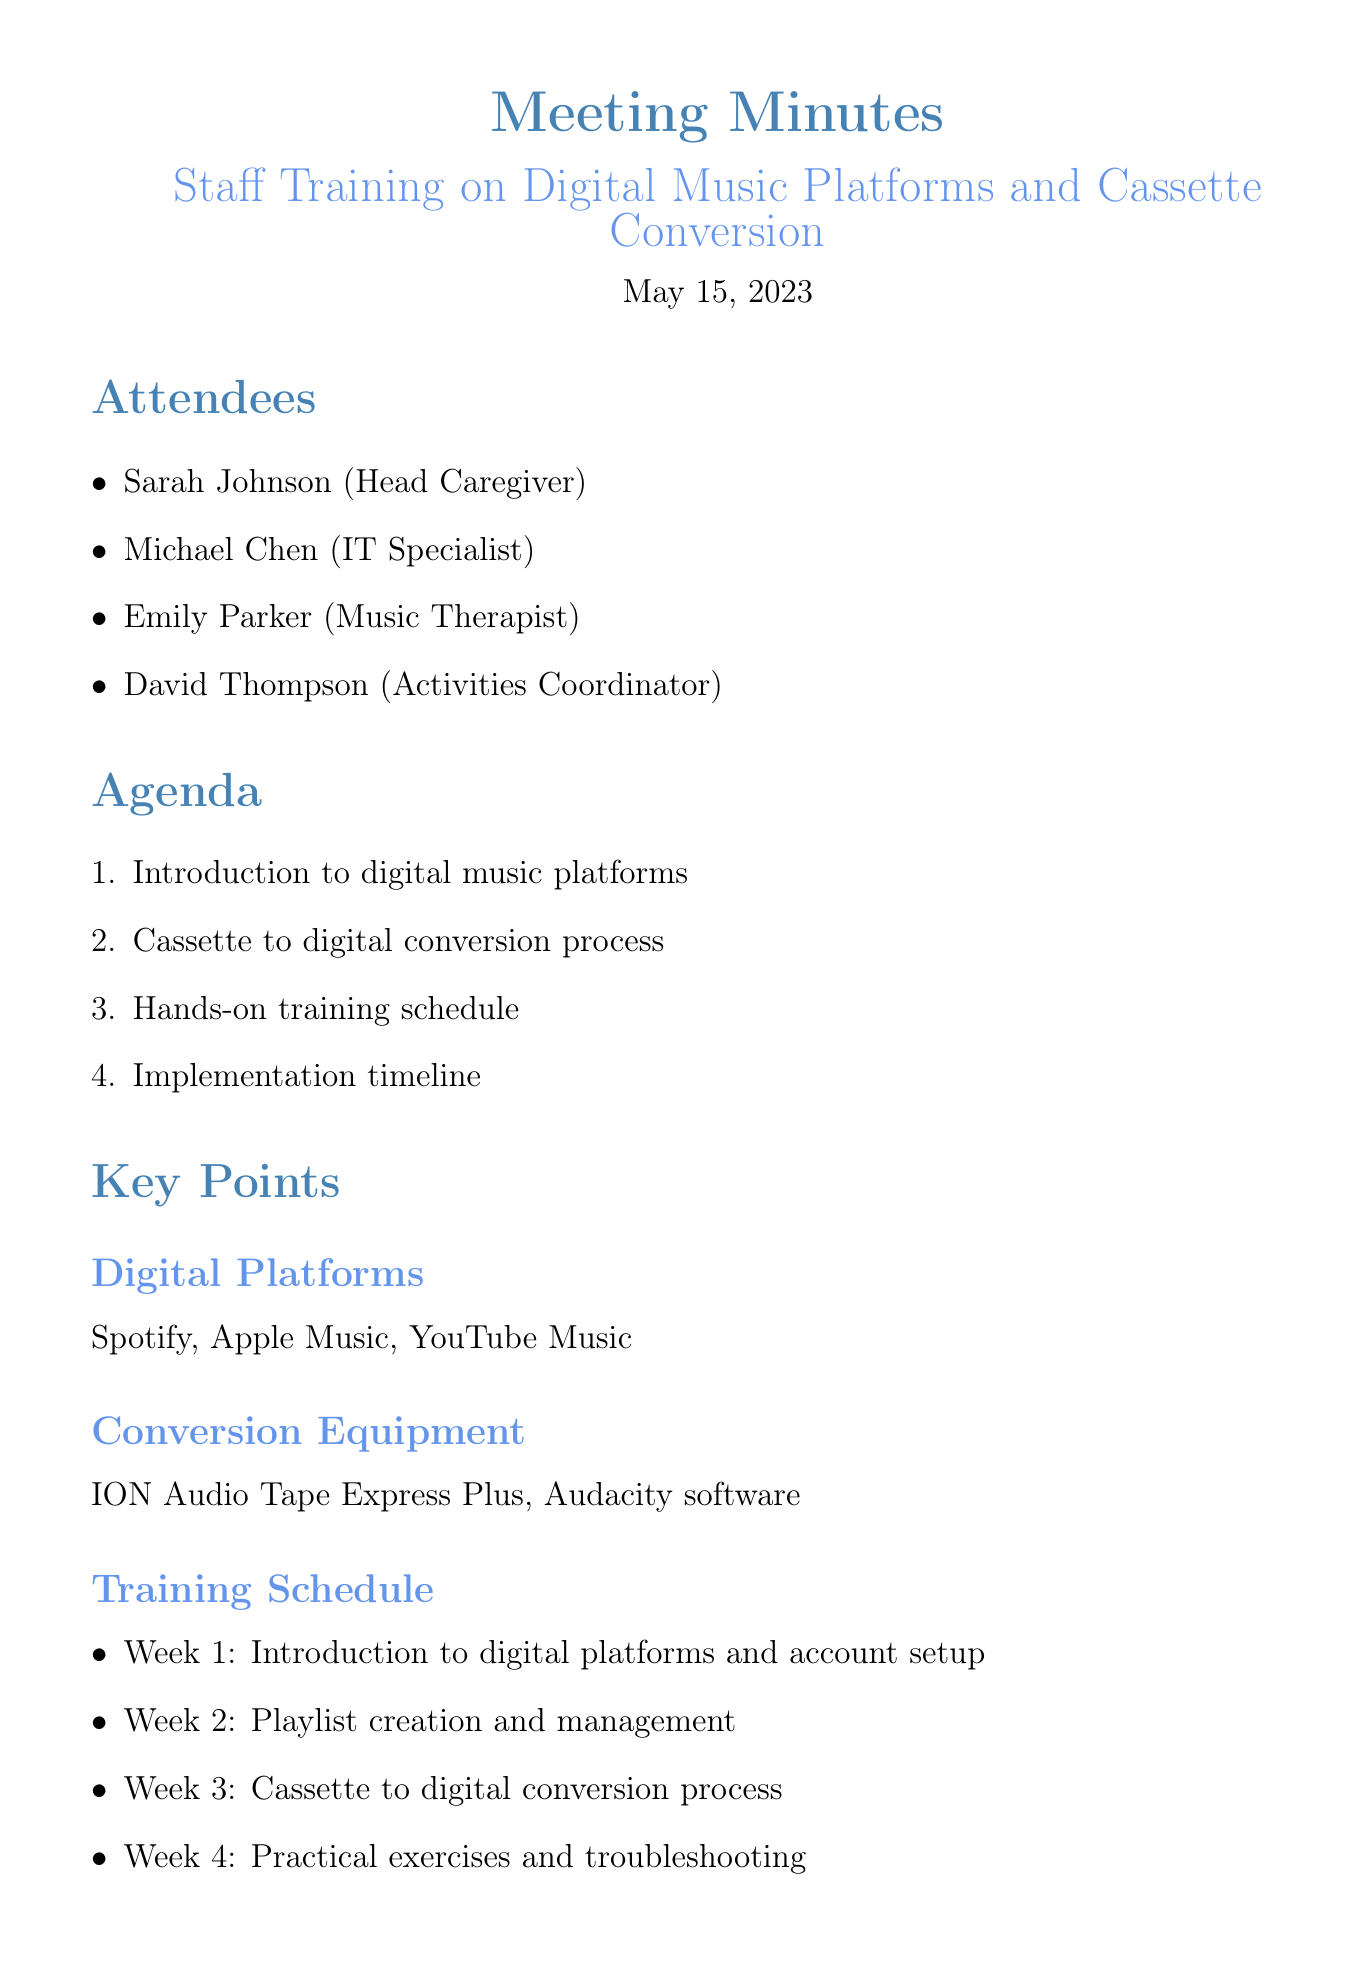what date was the meeting held? The meeting date is specified in the document as May 15, 2023.
Answer: May 15, 2023 who is the Head Caregiver? The document lists Sarah Johnson as the Head Caregiver in the attendees section.
Answer: Sarah Johnson what is the first topic in the agenda? The first item listed in the agenda is the introduction to digital music platforms.
Answer: Introduction to digital music platforms how many weeks is the training schedule planned for? The training schedule consists of four distinct weeks, as outlined in the document.
Answer: Four weeks what is the budget allocated for equipment purchase? The document specifies that the budget for equipment purchase is $500.
Answer: $500 which software is used for cassette conversion? The equipment section of the document mentions Audacity software for cassette conversion.
Answer: Audacity software when does the staff training begin? The implementation timeline indicates that staff training begins on June 1.
Answer: June 1 what is one of the key challenges mentioned? The document lists several challenges, with one being ensuring staff comfort with new technology.
Answer: Ensuring staff comfort with new technology what is the purpose of the meeting minutes? The minutes provide a summary of the discussions and decisions made during the meeting regarding staff training.
Answer: Staff training 